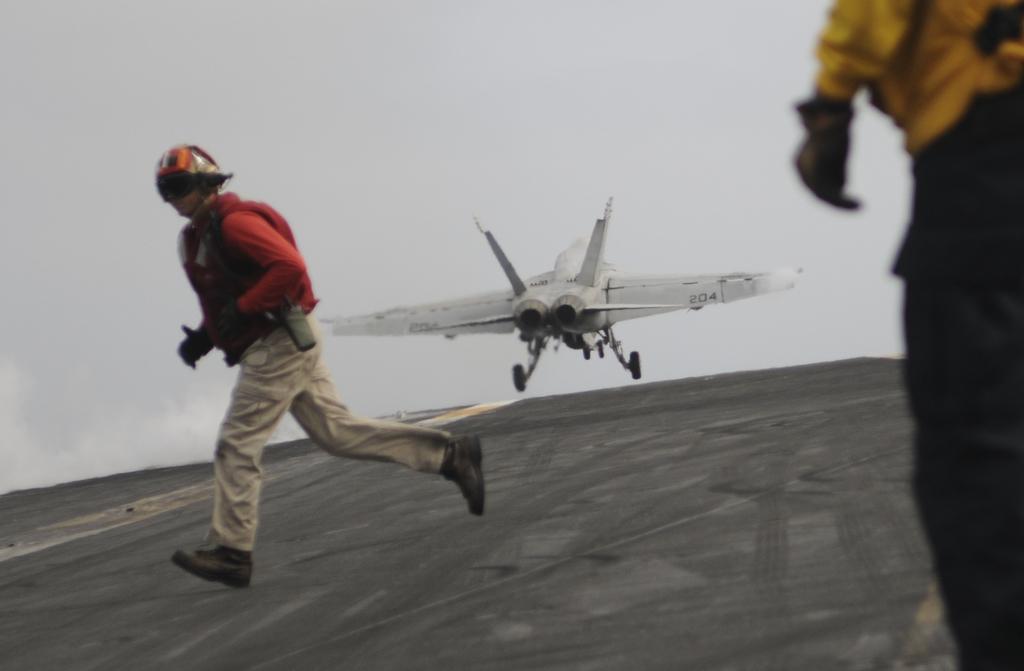Could you give a brief overview of what you see in this image? In this image I can see a person running wearing red shirt, cream pant and I can also see the other person standing. Background I can see an aircraft in white color and the sky is also in white color. 